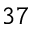Convert formula to latex. <formula><loc_0><loc_0><loc_500><loc_500>3 7</formula> 